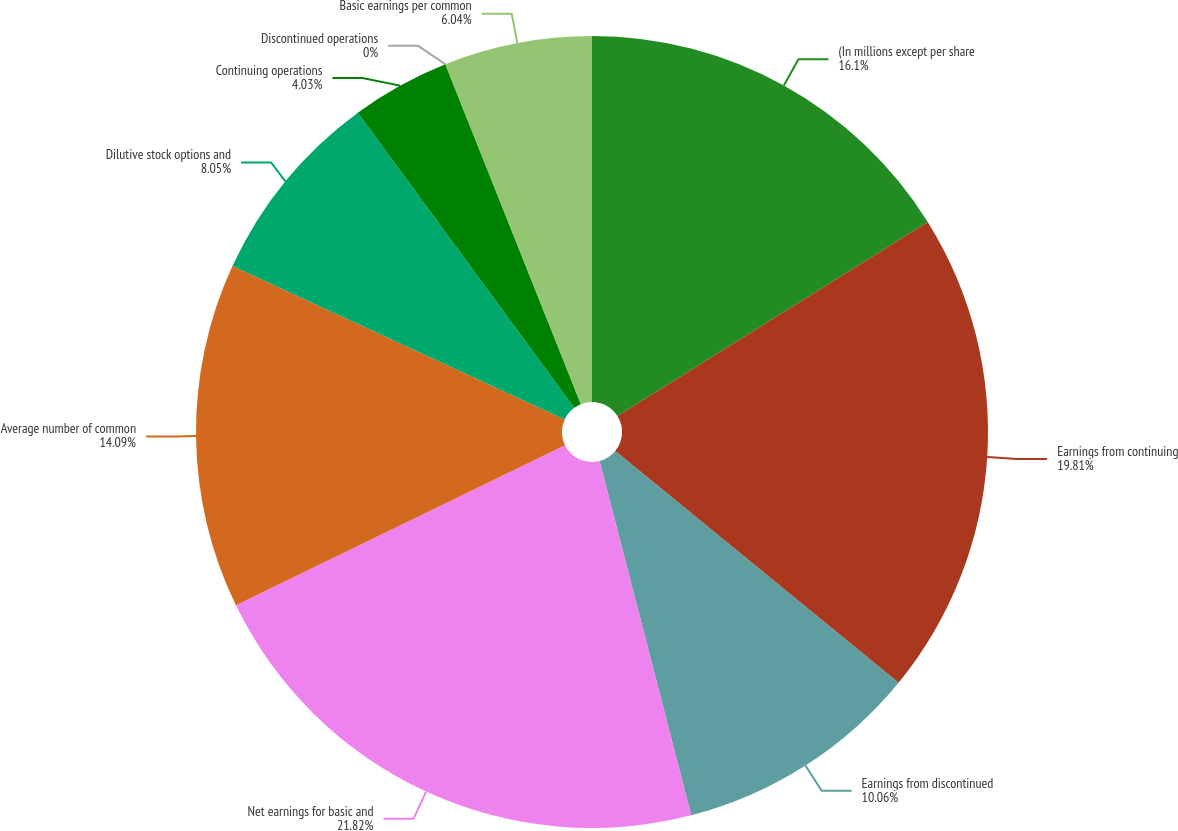<chart> <loc_0><loc_0><loc_500><loc_500><pie_chart><fcel>(In millions except per share<fcel>Earnings from continuing<fcel>Earnings from discontinued<fcel>Net earnings for basic and<fcel>Average number of common<fcel>Dilutive stock options and<fcel>Continuing operations<fcel>Discontinued operations<fcel>Basic earnings per common<nl><fcel>16.1%<fcel>19.81%<fcel>10.06%<fcel>21.82%<fcel>14.09%<fcel>8.05%<fcel>4.03%<fcel>0.0%<fcel>6.04%<nl></chart> 